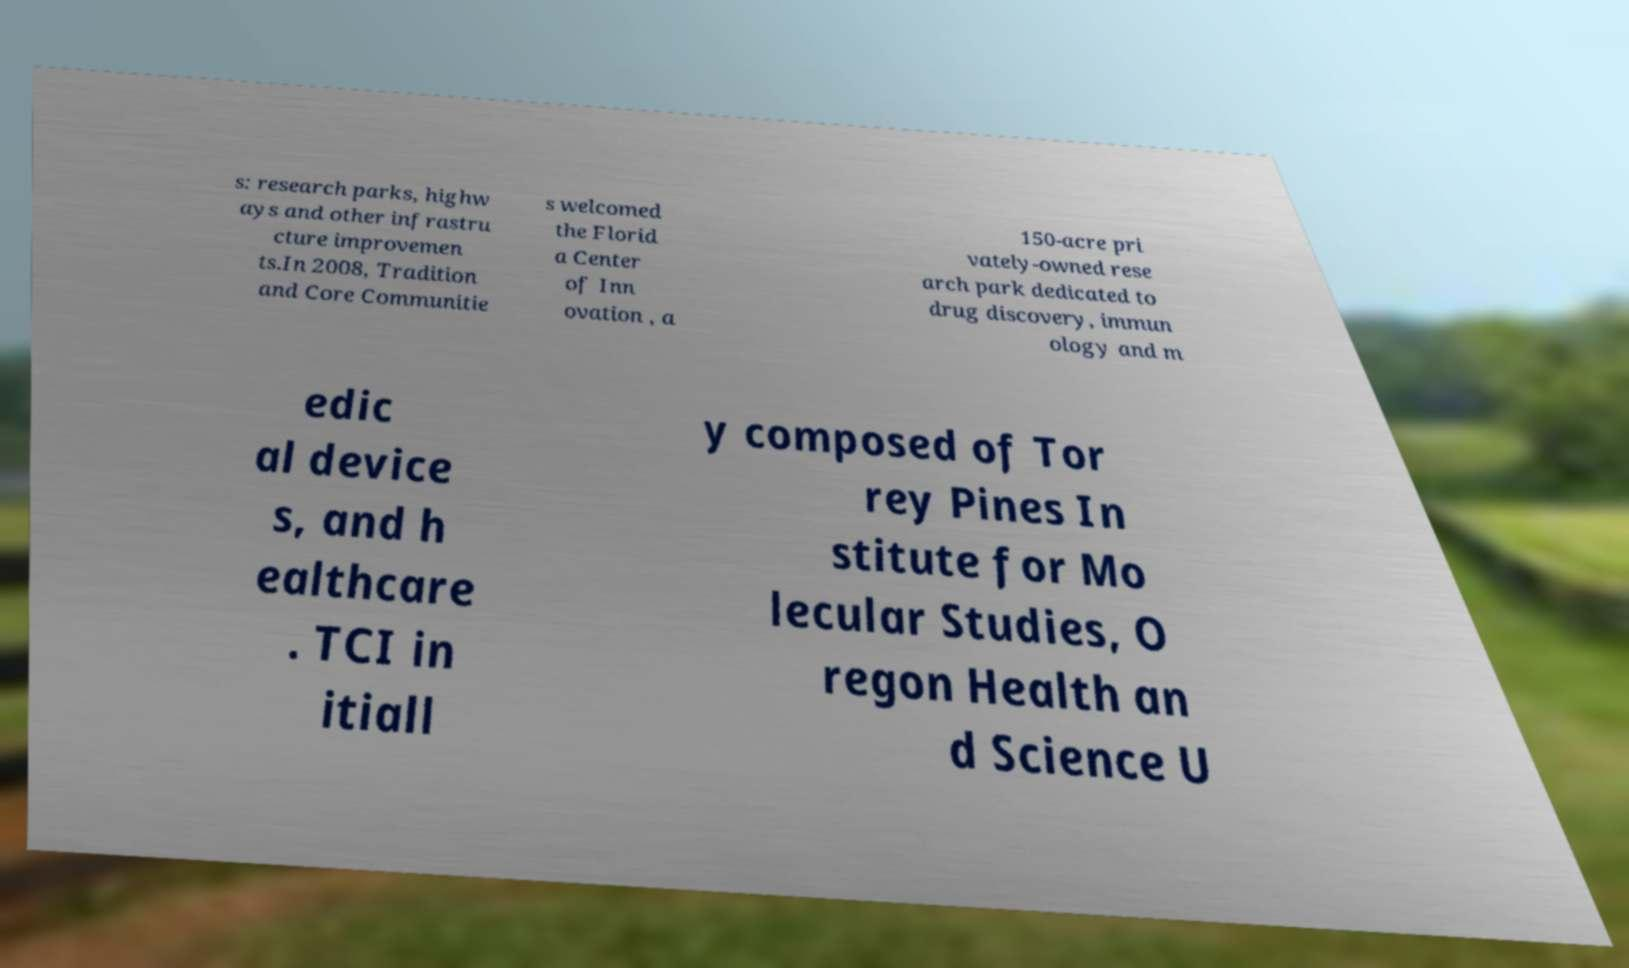Please read and relay the text visible in this image. What does it say? s: research parks, highw ays and other infrastru cture improvemen ts.In 2008, Tradition and Core Communitie s welcomed the Florid a Center of Inn ovation , a 150-acre pri vately-owned rese arch park dedicated to drug discovery, immun ology and m edic al device s, and h ealthcare . TCI in itiall y composed of Tor rey Pines In stitute for Mo lecular Studies, O regon Health an d Science U 